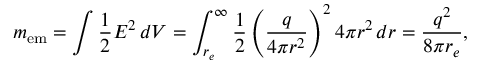<formula> <loc_0><loc_0><loc_500><loc_500>m _ { e m } = \int { \frac { 1 } { 2 } } E ^ { 2 } \, d V = \int _ { r _ { e } } ^ { \infty } { \frac { 1 } { 2 } } \left ( { \frac { q } { 4 \pi r ^ { 2 } } } \right ) ^ { 2 } 4 \pi r ^ { 2 } \, d r = { \frac { q ^ { 2 } } { 8 \pi r _ { e } } } ,</formula> 